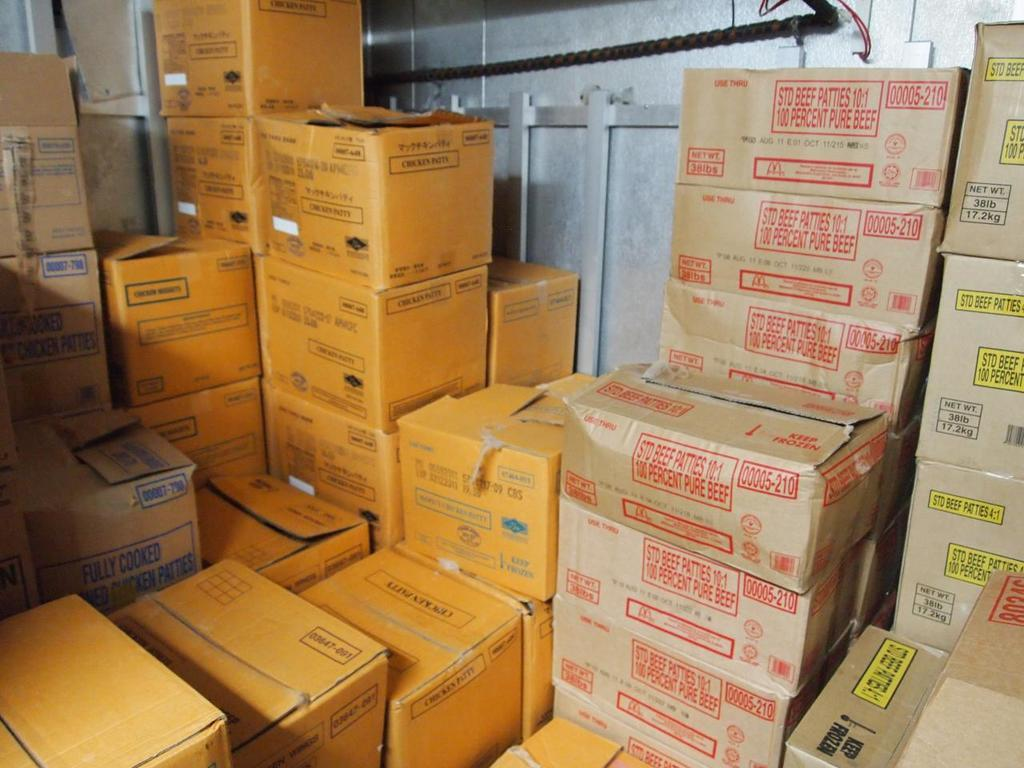<image>
Summarize the visual content of the image. Several boxes of food, including 100 percent pure beef patties. 